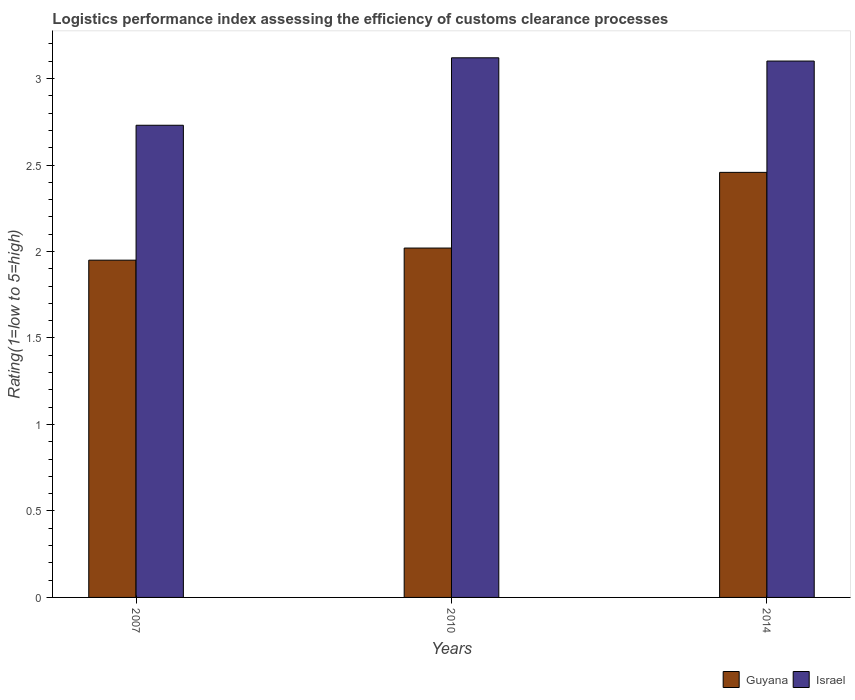How many different coloured bars are there?
Make the answer very short. 2. How many groups of bars are there?
Offer a very short reply. 3. Are the number of bars on each tick of the X-axis equal?
Offer a terse response. Yes. What is the Logistic performance index in Israel in 2010?
Your response must be concise. 3.12. Across all years, what is the maximum Logistic performance index in Guyana?
Your response must be concise. 2.46. Across all years, what is the minimum Logistic performance index in Israel?
Ensure brevity in your answer.  2.73. In which year was the Logistic performance index in Guyana maximum?
Offer a terse response. 2014. In which year was the Logistic performance index in Israel minimum?
Make the answer very short. 2007. What is the total Logistic performance index in Israel in the graph?
Offer a very short reply. 8.95. What is the difference between the Logistic performance index in Guyana in 2007 and that in 2014?
Make the answer very short. -0.51. What is the difference between the Logistic performance index in Israel in 2007 and the Logistic performance index in Guyana in 2010?
Offer a very short reply. 0.71. What is the average Logistic performance index in Israel per year?
Your answer should be compact. 2.98. In the year 2007, what is the difference between the Logistic performance index in Israel and Logistic performance index in Guyana?
Keep it short and to the point. 0.78. What is the ratio of the Logistic performance index in Guyana in 2010 to that in 2014?
Make the answer very short. 0.82. Is the Logistic performance index in Israel in 2007 less than that in 2010?
Provide a short and direct response. Yes. What is the difference between the highest and the second highest Logistic performance index in Israel?
Your response must be concise. 0.02. What is the difference between the highest and the lowest Logistic performance index in Guyana?
Ensure brevity in your answer.  0.51. In how many years, is the Logistic performance index in Guyana greater than the average Logistic performance index in Guyana taken over all years?
Keep it short and to the point. 1. What does the 1st bar from the left in 2014 represents?
Offer a very short reply. Guyana. What does the 2nd bar from the right in 2007 represents?
Give a very brief answer. Guyana. How many years are there in the graph?
Provide a succinct answer. 3. Are the values on the major ticks of Y-axis written in scientific E-notation?
Make the answer very short. No. Does the graph contain any zero values?
Give a very brief answer. No. Where does the legend appear in the graph?
Give a very brief answer. Bottom right. What is the title of the graph?
Ensure brevity in your answer.  Logistics performance index assessing the efficiency of customs clearance processes. Does "Bahrain" appear as one of the legend labels in the graph?
Provide a short and direct response. No. What is the label or title of the X-axis?
Provide a short and direct response. Years. What is the label or title of the Y-axis?
Your response must be concise. Rating(1=low to 5=high). What is the Rating(1=low to 5=high) in Guyana in 2007?
Provide a succinct answer. 1.95. What is the Rating(1=low to 5=high) of Israel in 2007?
Your response must be concise. 2.73. What is the Rating(1=low to 5=high) in Guyana in 2010?
Provide a short and direct response. 2.02. What is the Rating(1=low to 5=high) of Israel in 2010?
Offer a very short reply. 3.12. What is the Rating(1=low to 5=high) in Guyana in 2014?
Keep it short and to the point. 2.46. What is the Rating(1=low to 5=high) of Israel in 2014?
Offer a very short reply. 3.1. Across all years, what is the maximum Rating(1=low to 5=high) in Guyana?
Make the answer very short. 2.46. Across all years, what is the maximum Rating(1=low to 5=high) in Israel?
Ensure brevity in your answer.  3.12. Across all years, what is the minimum Rating(1=low to 5=high) in Guyana?
Offer a very short reply. 1.95. Across all years, what is the minimum Rating(1=low to 5=high) in Israel?
Provide a succinct answer. 2.73. What is the total Rating(1=low to 5=high) in Guyana in the graph?
Make the answer very short. 6.43. What is the total Rating(1=low to 5=high) in Israel in the graph?
Offer a terse response. 8.95. What is the difference between the Rating(1=low to 5=high) of Guyana in 2007 and that in 2010?
Provide a short and direct response. -0.07. What is the difference between the Rating(1=low to 5=high) of Israel in 2007 and that in 2010?
Ensure brevity in your answer.  -0.39. What is the difference between the Rating(1=low to 5=high) of Guyana in 2007 and that in 2014?
Your answer should be compact. -0.51. What is the difference between the Rating(1=low to 5=high) in Israel in 2007 and that in 2014?
Give a very brief answer. -0.37. What is the difference between the Rating(1=low to 5=high) of Guyana in 2010 and that in 2014?
Make the answer very short. -0.44. What is the difference between the Rating(1=low to 5=high) of Israel in 2010 and that in 2014?
Your response must be concise. 0.02. What is the difference between the Rating(1=low to 5=high) of Guyana in 2007 and the Rating(1=low to 5=high) of Israel in 2010?
Keep it short and to the point. -1.17. What is the difference between the Rating(1=low to 5=high) of Guyana in 2007 and the Rating(1=low to 5=high) of Israel in 2014?
Ensure brevity in your answer.  -1.15. What is the difference between the Rating(1=low to 5=high) of Guyana in 2010 and the Rating(1=low to 5=high) of Israel in 2014?
Keep it short and to the point. -1.08. What is the average Rating(1=low to 5=high) in Guyana per year?
Offer a terse response. 2.14. What is the average Rating(1=low to 5=high) in Israel per year?
Provide a short and direct response. 2.98. In the year 2007, what is the difference between the Rating(1=low to 5=high) in Guyana and Rating(1=low to 5=high) in Israel?
Provide a short and direct response. -0.78. In the year 2014, what is the difference between the Rating(1=low to 5=high) of Guyana and Rating(1=low to 5=high) of Israel?
Your response must be concise. -0.64. What is the ratio of the Rating(1=low to 5=high) in Guyana in 2007 to that in 2010?
Keep it short and to the point. 0.97. What is the ratio of the Rating(1=low to 5=high) in Guyana in 2007 to that in 2014?
Provide a short and direct response. 0.79. What is the ratio of the Rating(1=low to 5=high) of Israel in 2007 to that in 2014?
Your answer should be compact. 0.88. What is the ratio of the Rating(1=low to 5=high) of Guyana in 2010 to that in 2014?
Provide a succinct answer. 0.82. What is the difference between the highest and the second highest Rating(1=low to 5=high) of Guyana?
Provide a short and direct response. 0.44. What is the difference between the highest and the second highest Rating(1=low to 5=high) of Israel?
Make the answer very short. 0.02. What is the difference between the highest and the lowest Rating(1=low to 5=high) in Guyana?
Offer a terse response. 0.51. What is the difference between the highest and the lowest Rating(1=low to 5=high) in Israel?
Ensure brevity in your answer.  0.39. 